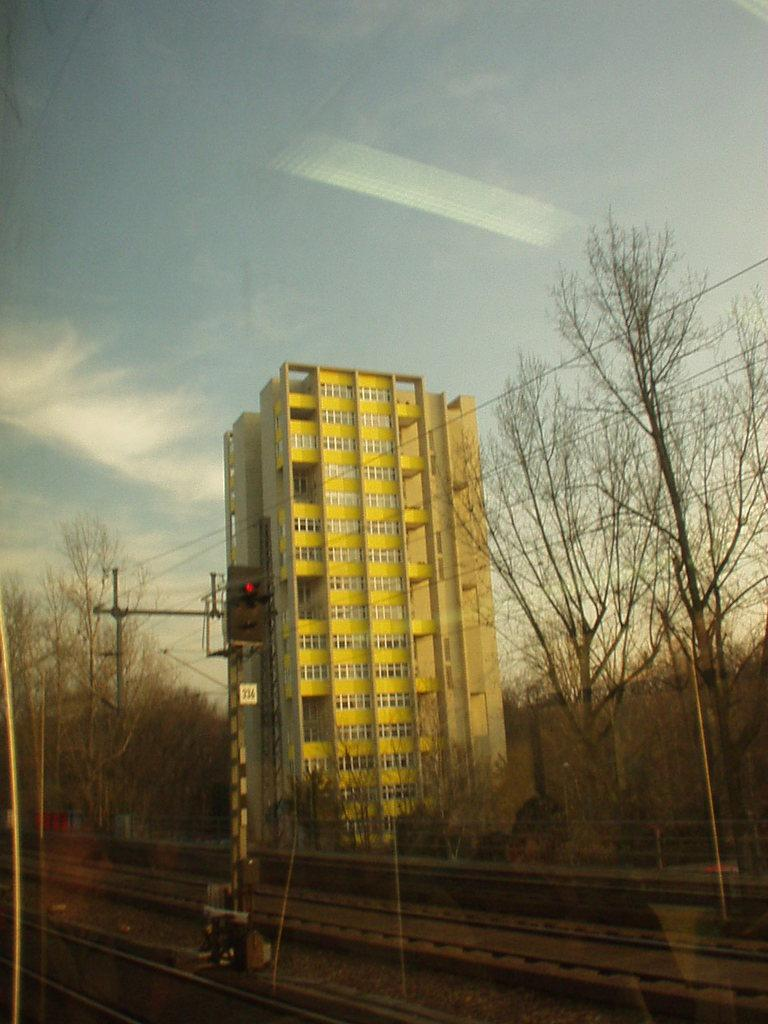What type of transportation infrastructure is present in the image? There are railway tracks in the image. What type of structure is located near the railway tracks? There is a building with windows in the image. What type of natural elements can be seen in the image? There are trees in the image. What safety feature is present near the railway tracks? Signal lights are visible in the image. What is visible in the background of the image? The sky is visible in the image. How many rings are visible on the fingers of the person in the image? There is no person present in the image, so it is not possible to determine if there are any rings visible. 